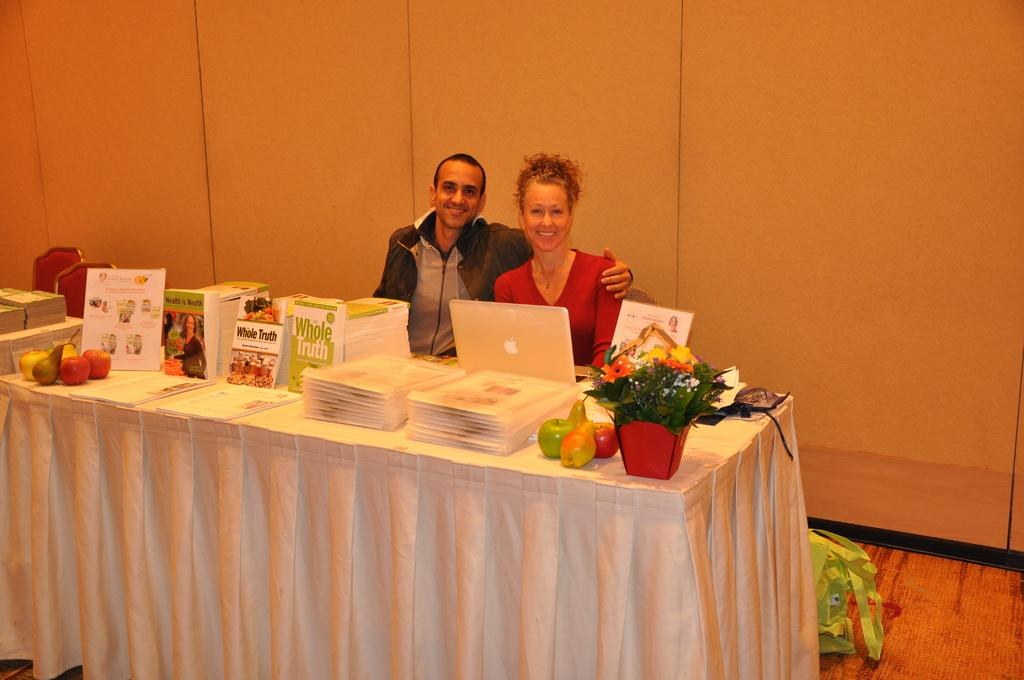What type of furniture is present in the image? There are tables and chairs in the image. What items can be seen on the tables? There are books and fruits on the table. How many people are in the image? There are two people in the image. What type of background is visible in the image? There is a wall and a floor in the image. What type of account does the territory in the image represent? There is no territory present in the image, and therefore no account can be associated with it. What is the taste of the fruits on the table in the image? The taste of the fruits cannot be determined from the image alone, as taste is a sensory experience. 